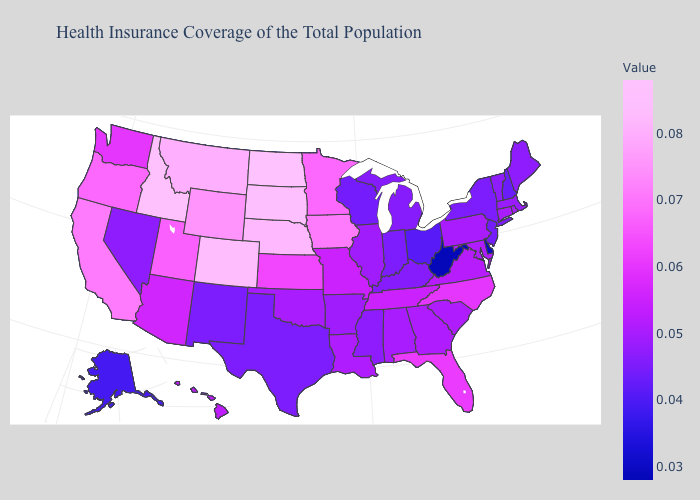Among the states that border Utah , which have the highest value?
Be succinct. Idaho. Which states hav the highest value in the Northeast?
Give a very brief answer. Connecticut, Pennsylvania, Rhode Island. Does North Dakota have the highest value in the USA?
Give a very brief answer. Yes. Does Colorado have the lowest value in the USA?
Answer briefly. No. Does the map have missing data?
Give a very brief answer. No. Does the map have missing data?
Be succinct. No. Which states have the lowest value in the Northeast?
Give a very brief answer. New Hampshire. Among the states that border Iowa , does Missouri have the highest value?
Write a very short answer. No. 